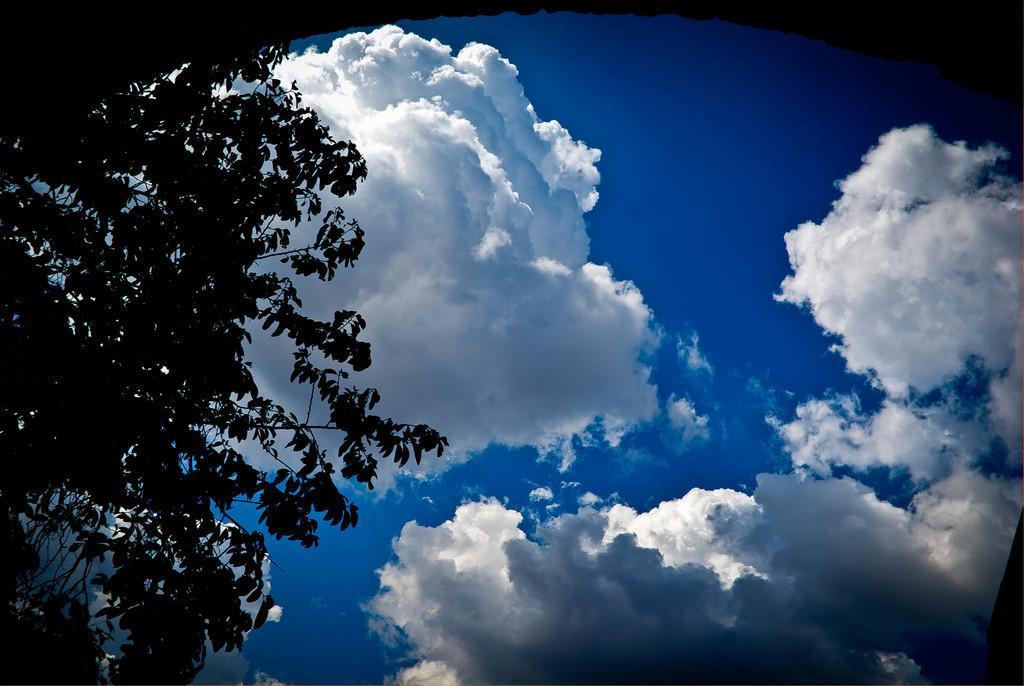Can you describe this image briefly? On the left side there are branches of trees. In the back there is sky with clouds. 